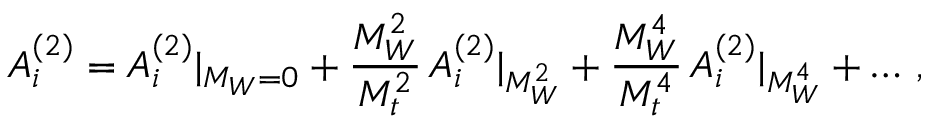<formula> <loc_0><loc_0><loc_500><loc_500>A _ { i } ^ { ( 2 ) } = A _ { i } ^ { ( 2 ) } | _ { M _ { W } = 0 } + { \frac { M _ { W } ^ { 2 } } { M _ { t } ^ { 2 } } } \, A _ { i } ^ { ( 2 ) } | _ { M _ { W } ^ { 2 } } + { \frac { M _ { W } ^ { 4 } } { M _ { t } ^ { 4 } } } \, A _ { i } ^ { ( 2 ) } | _ { M _ { W } ^ { 4 } } + \dots \, ,</formula> 